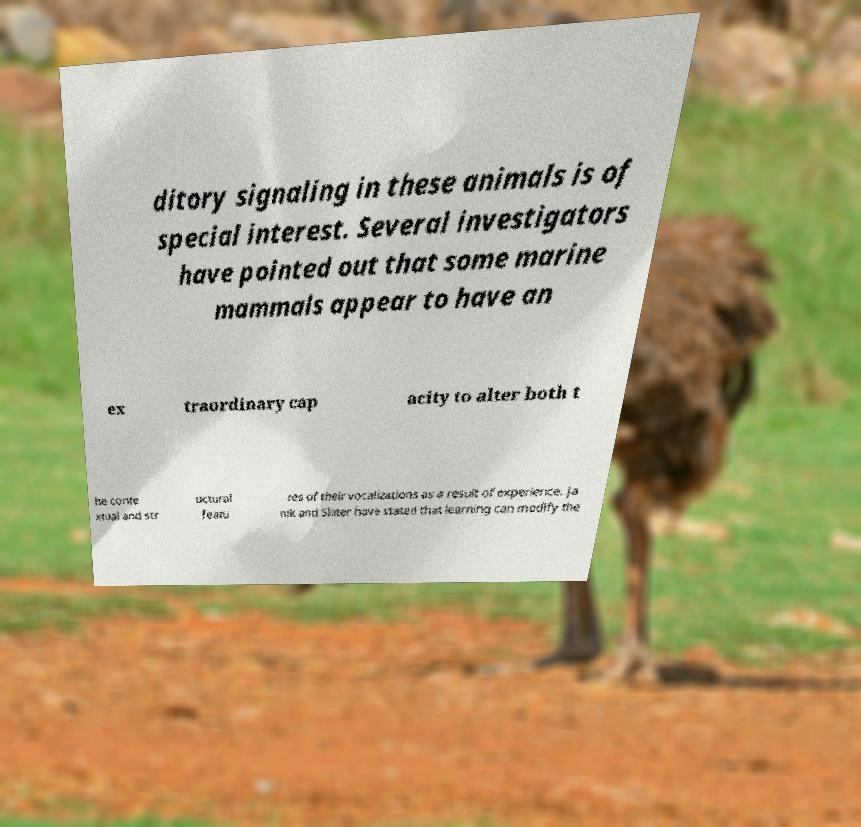Please read and relay the text visible in this image. What does it say? ditory signaling in these animals is of special interest. Several investigators have pointed out that some marine mammals appear to have an ex traordinary cap acity to alter both t he conte xtual and str uctural featu res of their vocalizations as a result of experience. Ja nik and Slater have stated that learning can modify the 